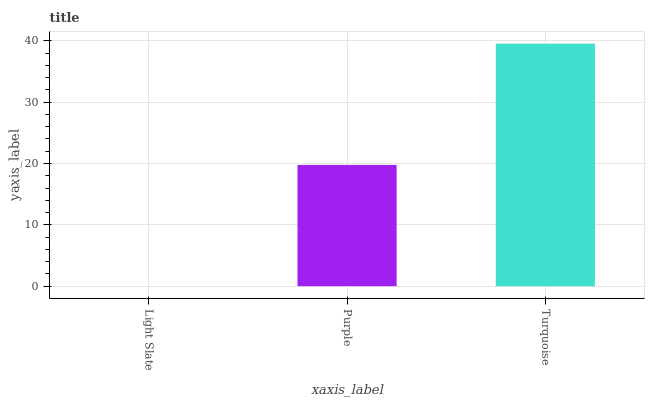Is Purple the minimum?
Answer yes or no. No. Is Purple the maximum?
Answer yes or no. No. Is Purple greater than Light Slate?
Answer yes or no. Yes. Is Light Slate less than Purple?
Answer yes or no. Yes. Is Light Slate greater than Purple?
Answer yes or no. No. Is Purple less than Light Slate?
Answer yes or no. No. Is Purple the high median?
Answer yes or no. Yes. Is Purple the low median?
Answer yes or no. Yes. Is Turquoise the high median?
Answer yes or no. No. Is Light Slate the low median?
Answer yes or no. No. 